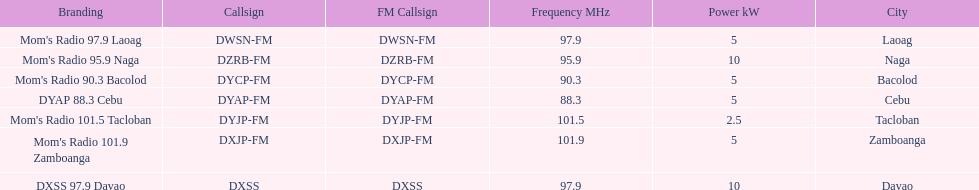What is the difference in kw between naga and bacolod radio? 5 kW. 